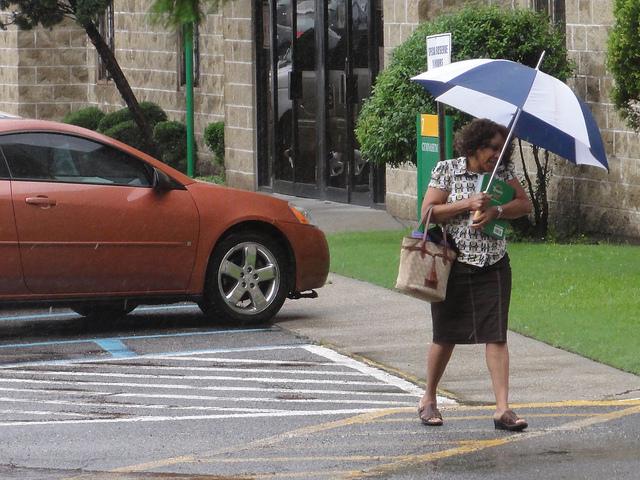What is this woman holding to cover her head?
Be succinct. Umbrella. What is on the woman's arm?
Write a very short answer. Purse. What kind of car is in the picture?
Give a very brief answer. Coupe. 